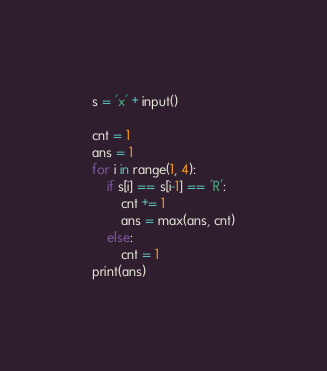<code> <loc_0><loc_0><loc_500><loc_500><_Python_>s = 'x' + input()

cnt = 1
ans = 1
for i in range(1, 4):
    if s[i] == s[i-1] == 'R':
        cnt += 1
        ans = max(ans, cnt)
    else:
        cnt = 1
print(ans)</code> 